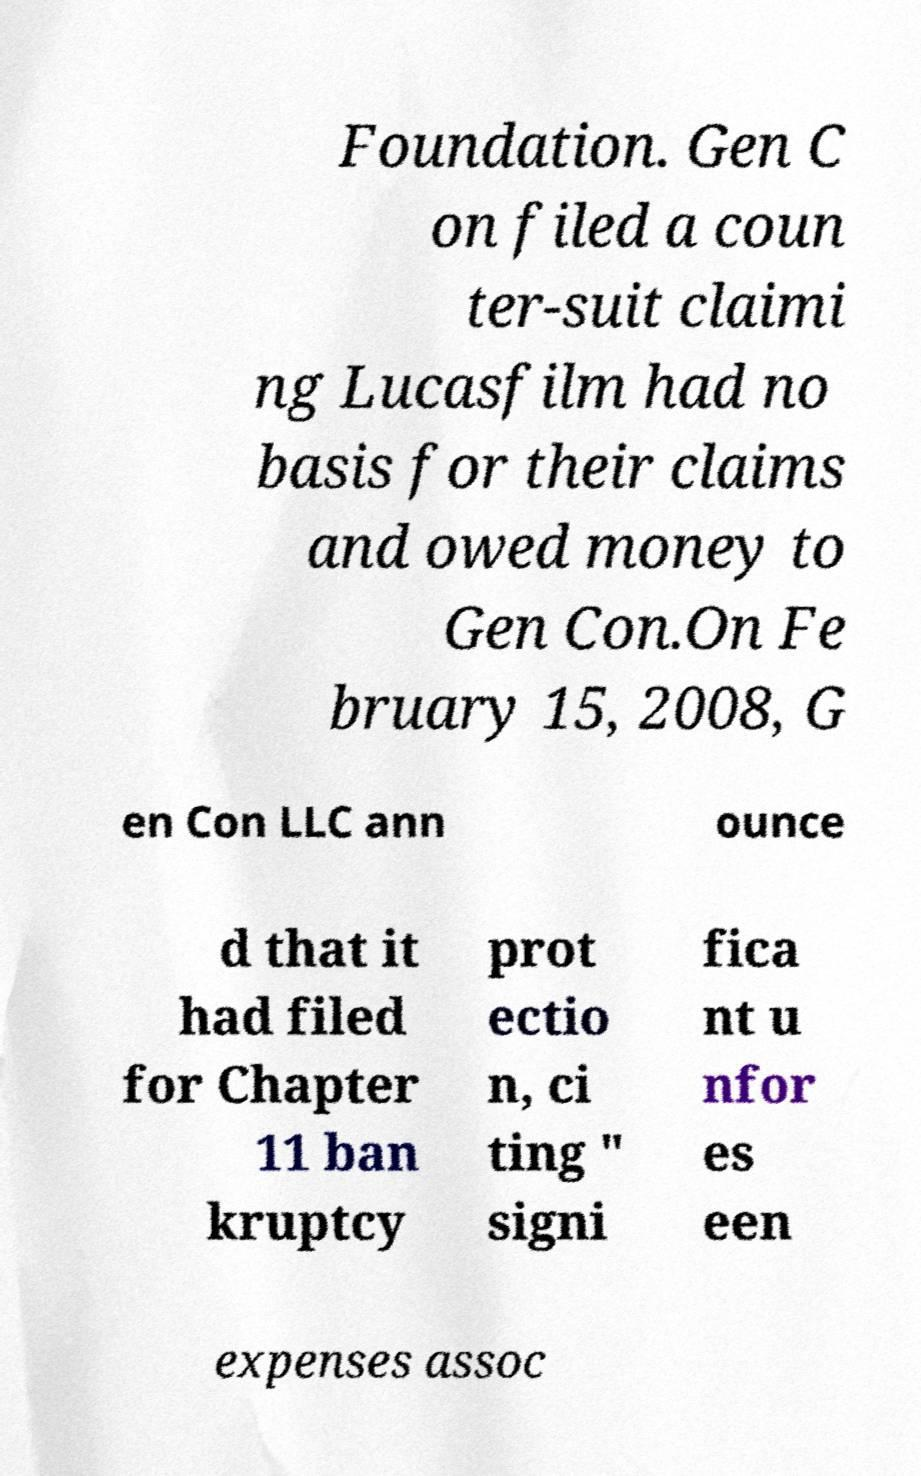I need the written content from this picture converted into text. Can you do that? Foundation. Gen C on filed a coun ter-suit claimi ng Lucasfilm had no basis for their claims and owed money to Gen Con.On Fe bruary 15, 2008, G en Con LLC ann ounce d that it had filed for Chapter 11 ban kruptcy prot ectio n, ci ting " signi fica nt u nfor es een expenses assoc 